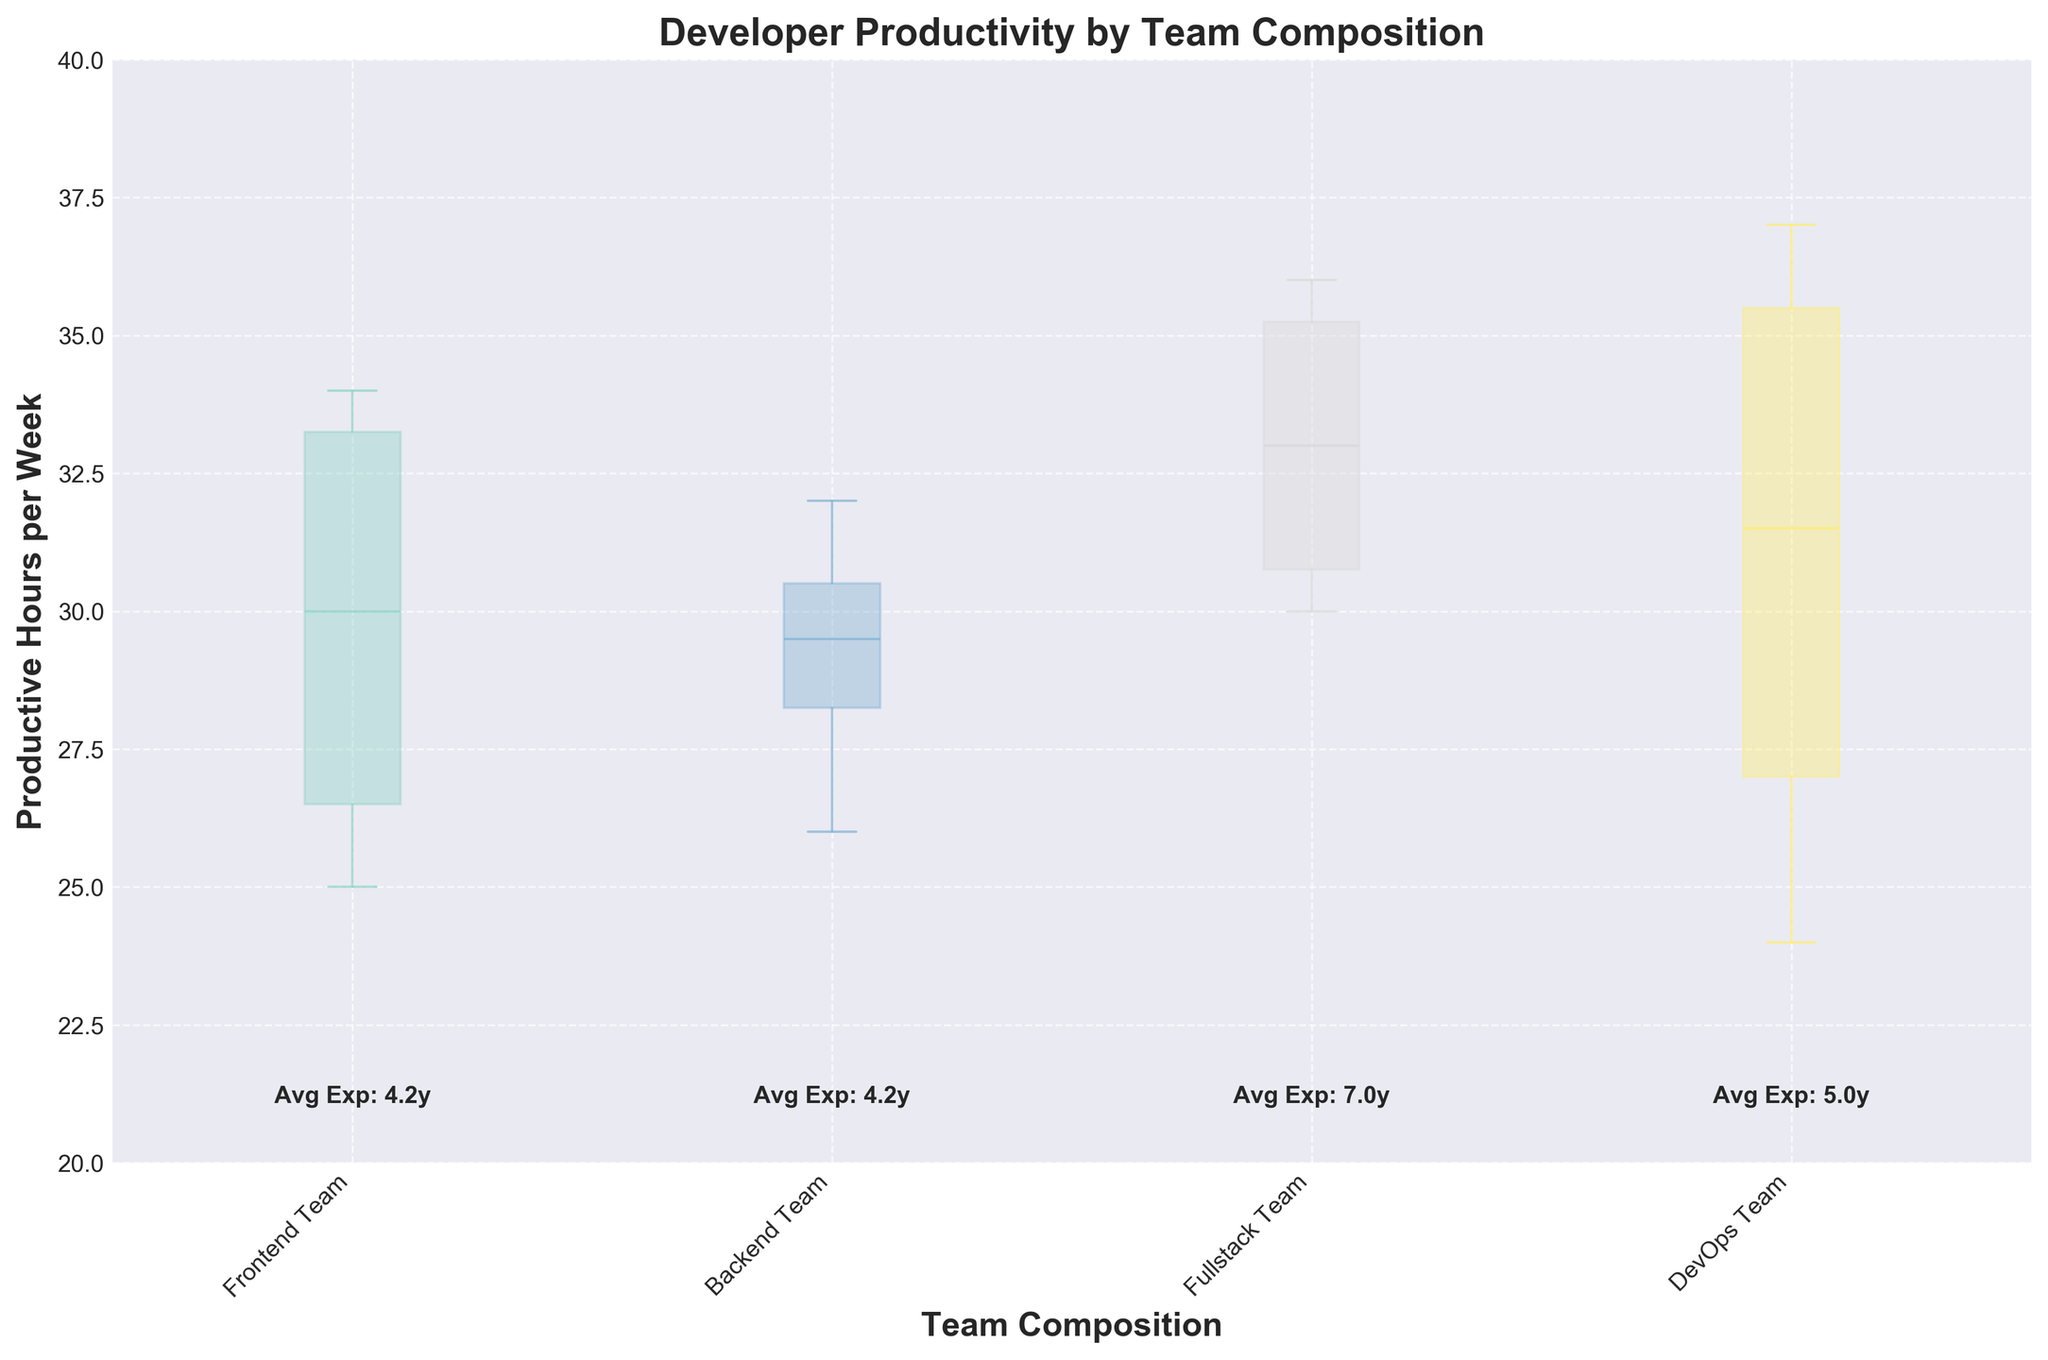What is the title of the plot? The title of the plot is located at the top of the figure, which describes the main topic represented by the data shown. In this case, the title given is "Developer Productivity by Team Composition".
Answer: Developer Productivity by Team Composition Which team has the widest box plot? The width of the box plots in this variable-width box plot is proportional to the number of data points within each team. The Fullstack Team has the widest box plot, indicating it has the most data points.
Answer: Fullstack Team What is the y-axis label? The y-axis label is found on the vertical axis of the plot and describes what is being measured along that axis. Here, it is labeled as "Productive Hours per Week".
Answer: Productive Hours per Week What is the range of productive hours for the Frontend Team? To find the range, check the bottom and top of the box, which represents the interquartile range (25th to 75th percentiles), and the whiskers which extend to show the minimum and maximum values. For the Frontend Team, the range is approximately from 25 to 34 hours per week.
Answer: 25 to 34 hours per week Which team has the highest median productive hours per week? The median of each team's productive hours is marked by the line inside the box. For the DevOps Team, the median line is the highest among all teams, suggesting that they have the highest median productive hours per week.
Answer: DevOps Team What is the average years of experience for the Fullstack Team? The average years of experience is displayed as text below each team's box plot. For the Fullstack Team, the text indicates an average experience of 7.0 years.
Answer: 7.0 years What is the minimum productive hours per week observed across all teams? The minimum productive hours per week can be identified by looking at the lowest point of the whiskers across all box plots. The DevOps Team has the minimum productive hours at 24 hours per week.
Answer: 24 hours per week How does the Backend Team's median productive hours compare to the Frontend Team's median productive hours? To compare medians, look at the line inside each team's box plot. The Backend Team's median productive hours are slightly higher than the Frontend Team's median productive hours.
Answer: Backend Team has higher median How do we interpret the variable widths of the box plots in this figure? The variable widths of the box plots indicate the relative number of data points for each team. A wider box represents a larger number of team members providing data, while a narrower box means fewer data points.
Answer: Relative number of data points Based on the figure, which team appears to have the most consistent (least varied) productivity? Consistency in productivity can be inferred from the interquartile range; a shorter box suggests less variability. The Backend Team has the shortest box indicating the least variation in productive hours among its members.
Answer: Backend Team 